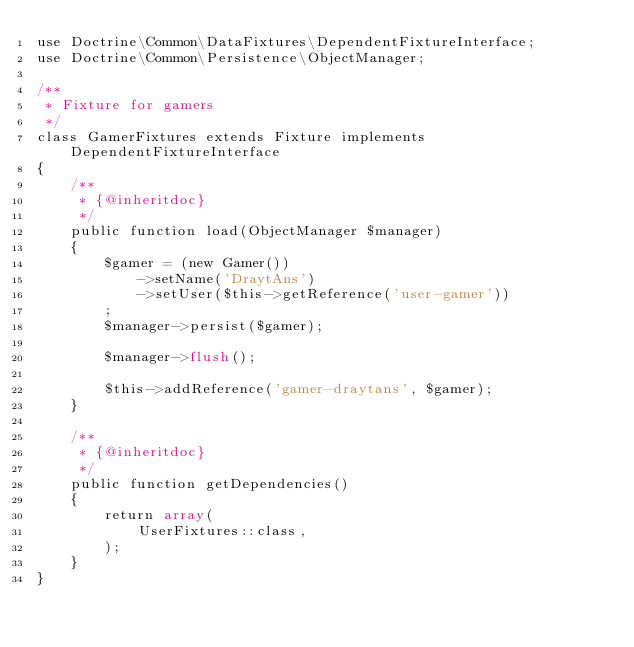Convert code to text. <code><loc_0><loc_0><loc_500><loc_500><_PHP_>use Doctrine\Common\DataFixtures\DependentFixtureInterface;
use Doctrine\Common\Persistence\ObjectManager;

/**
 * Fixture for gamers
 */
class GamerFixtures extends Fixture implements DependentFixtureInterface
{
    /**
     * {@inheritdoc}
     */
    public function load(ObjectManager $manager)
    {
        $gamer = (new Gamer())
            ->setName('DraytAns')
            ->setUser($this->getReference('user-gamer'))
        ;
        $manager->persist($gamer);

        $manager->flush();

        $this->addReference('gamer-draytans', $gamer);
    }

    /**
     * {@inheritdoc}
     */
    public function getDependencies()
    {
        return array(
            UserFixtures::class,
        );
    }
}
</code> 